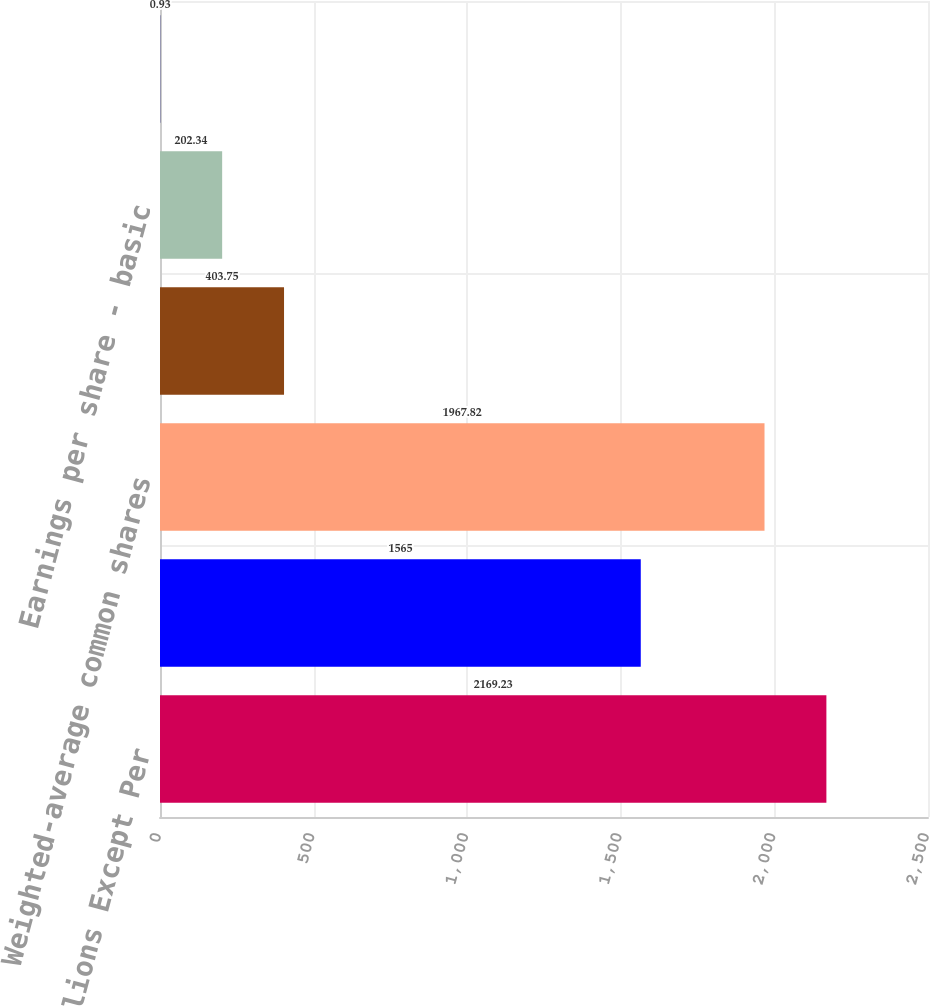<chart> <loc_0><loc_0><loc_500><loc_500><bar_chart><fcel>Amounts in Millions Except Per<fcel>Net Earnings Attributable to<fcel>Weighted-average common shares<fcel>Incremental shares<fcel>Earnings per share - basic<fcel>Earnings per share - diluted<nl><fcel>2169.23<fcel>1565<fcel>1967.82<fcel>403.75<fcel>202.34<fcel>0.93<nl></chart> 